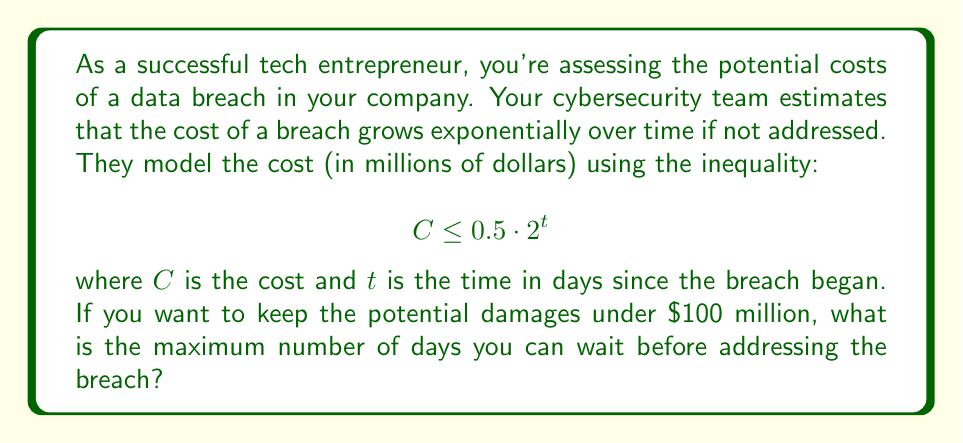Provide a solution to this math problem. To solve this problem, we need to use the given exponential inequality and solve for $t$:

1) We start with the inequality:
   $$ C \leq 0.5 \cdot 2^t $$

2) We want to find the maximum $t$ when $C = 100$ (as we want to keep damages under $100 million):
   $$ 100 \leq 0.5 \cdot 2^t $$

3) Divide both sides by 0.5:
   $$ 200 \leq 2^t $$

4) Take the logarithm (base 2) of both sides:
   $$ \log_2(200) \leq \log_2(2^t) $$

5) Simplify the right side using the logarithm property $\log_a(a^x) = x$:
   $$ \log_2(200) \leq t $$

6) Calculate $\log_2(200)$:
   $$ t \geq \log_2(200) \approx 7.64386 $$

7) Since we're looking for the maximum number of whole days, we round down to the nearest integer:
   $$ t \leq 7 $$

Therefore, the maximum number of days you can wait before addressing the breach is 7 days.
Answer: 7 days 